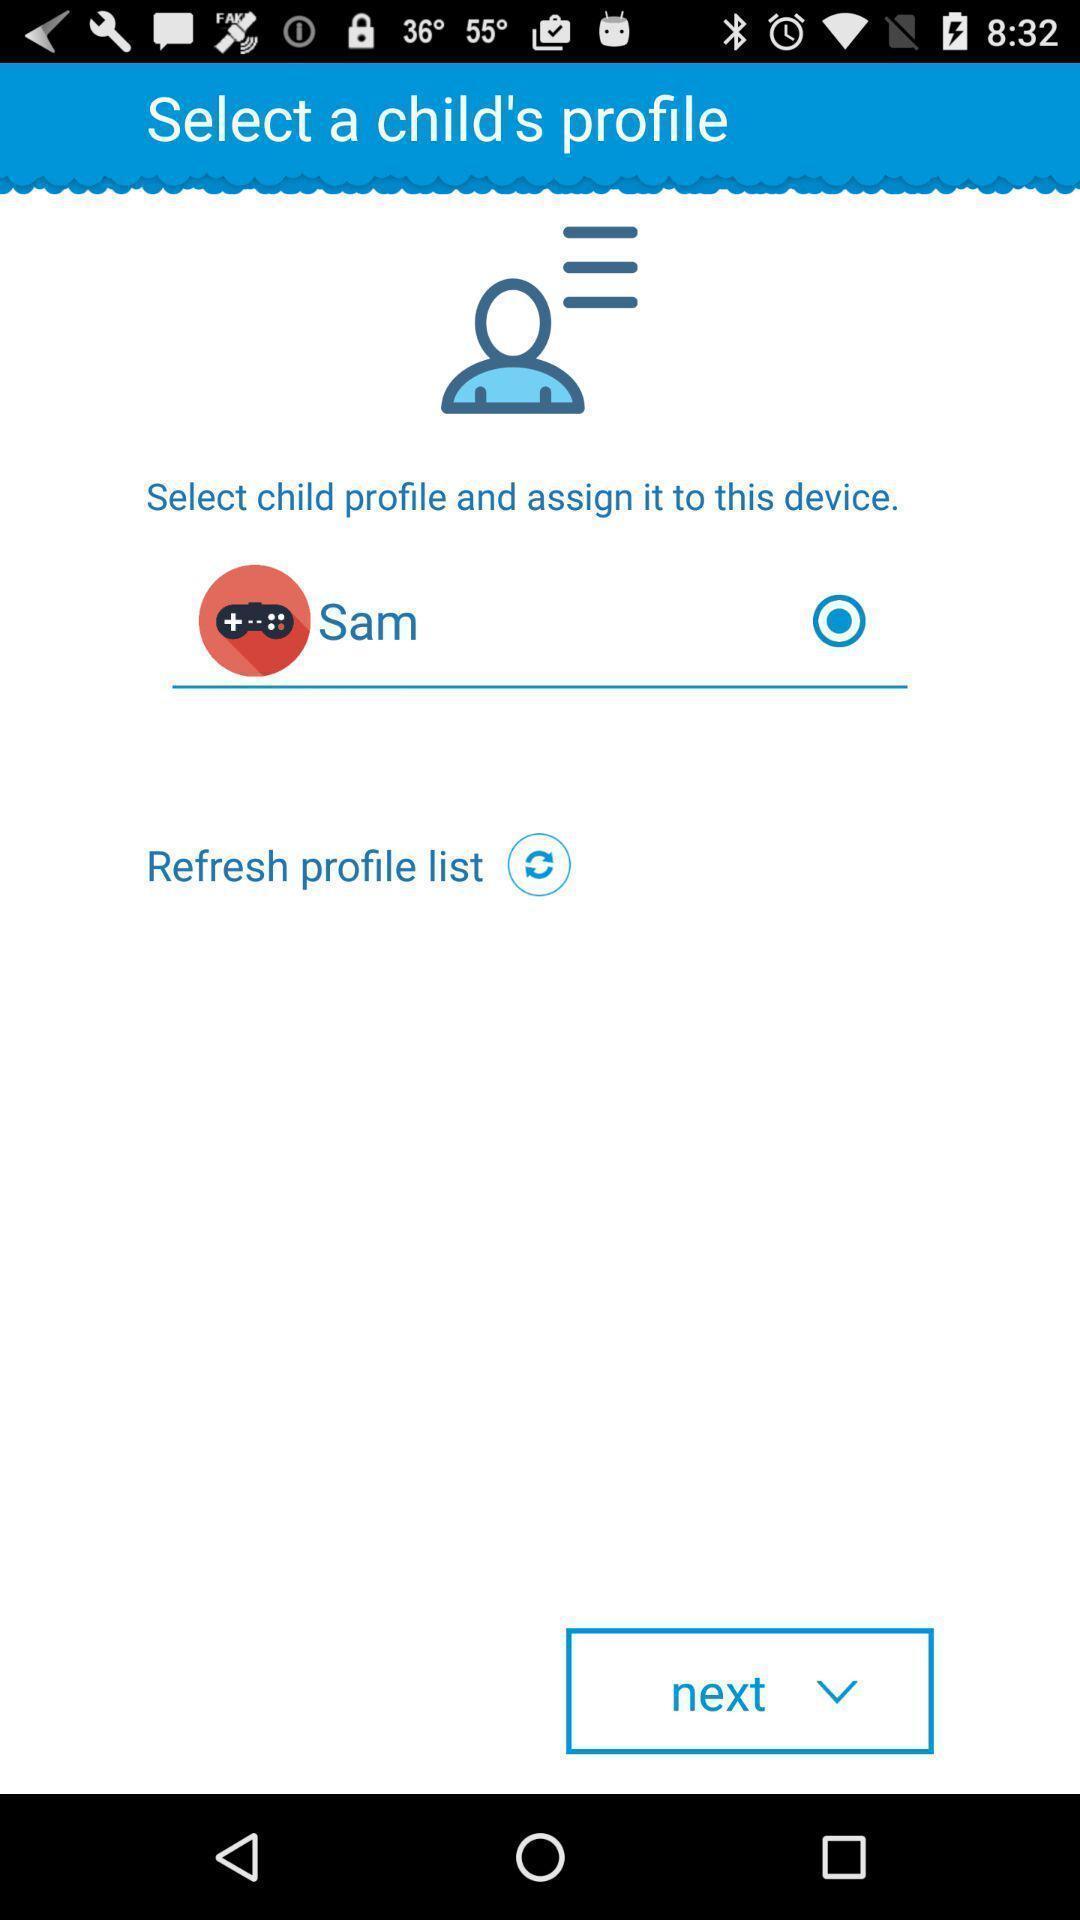Provide a detailed account of this screenshot. Select profile page of a social app. 